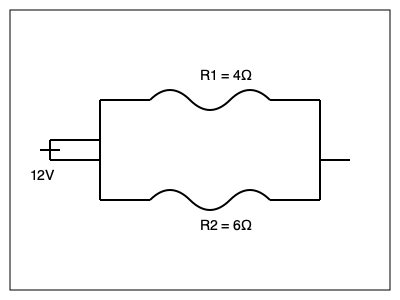In the given circuit diagram, two resistors R1 and R2 are connected in parallel with a 12V battery. If R1 = 4Ω and R2 = 6Ω, what is the total current flowing through the circuit? To find the total current, we'll follow these steps:

1. Calculate the equivalent resistance (Req) of the parallel circuit:
   $\frac{1}{R_{eq}} = \frac{1}{R_1} + \frac{1}{R_2}$
   $\frac{1}{R_{eq}} = \frac{1}{4} + \frac{1}{6} = \frac{3}{12} + \frac{2}{12} = \frac{5}{12}$
   $R_{eq} = \frac{12}{5} = 2.4\Omega$

2. Use Ohm's Law to calculate the total current:
   $I = \frac{V}{R_{eq}}$
   Where V is the voltage (12V) and Req is the equivalent resistance (2.4Ω)

3. Plug in the values:
   $I = \frac{12V}{2.4\Omega} = 5A$

Therefore, the total current flowing through the circuit is 5 amperes.
Answer: 5A 